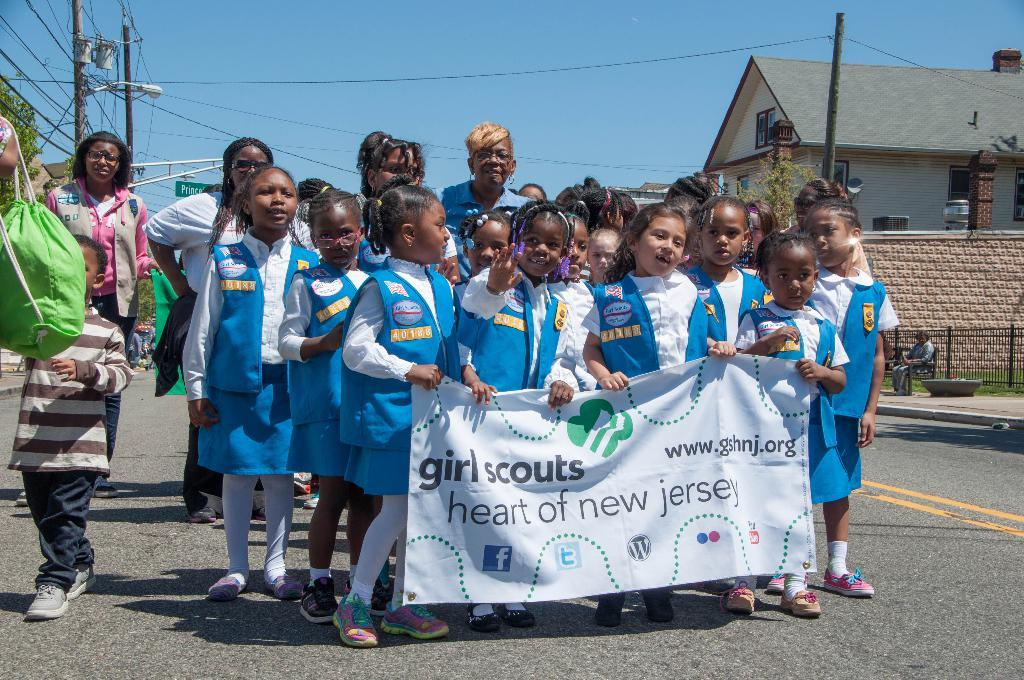What is the main subject of the image? The main subject of the image is a group of kids. What are the kids holding in the image? The kids are holding something with text written on it. What can be seen in the background of the image? There is a house and the sky visible in the background of the image. What type of coal is being used by the tiger in the image? There is no tiger or coal present in the image. What government policy is being discussed by the kids in the image? The image does not provide any information about government policies or discussions among the kids. 